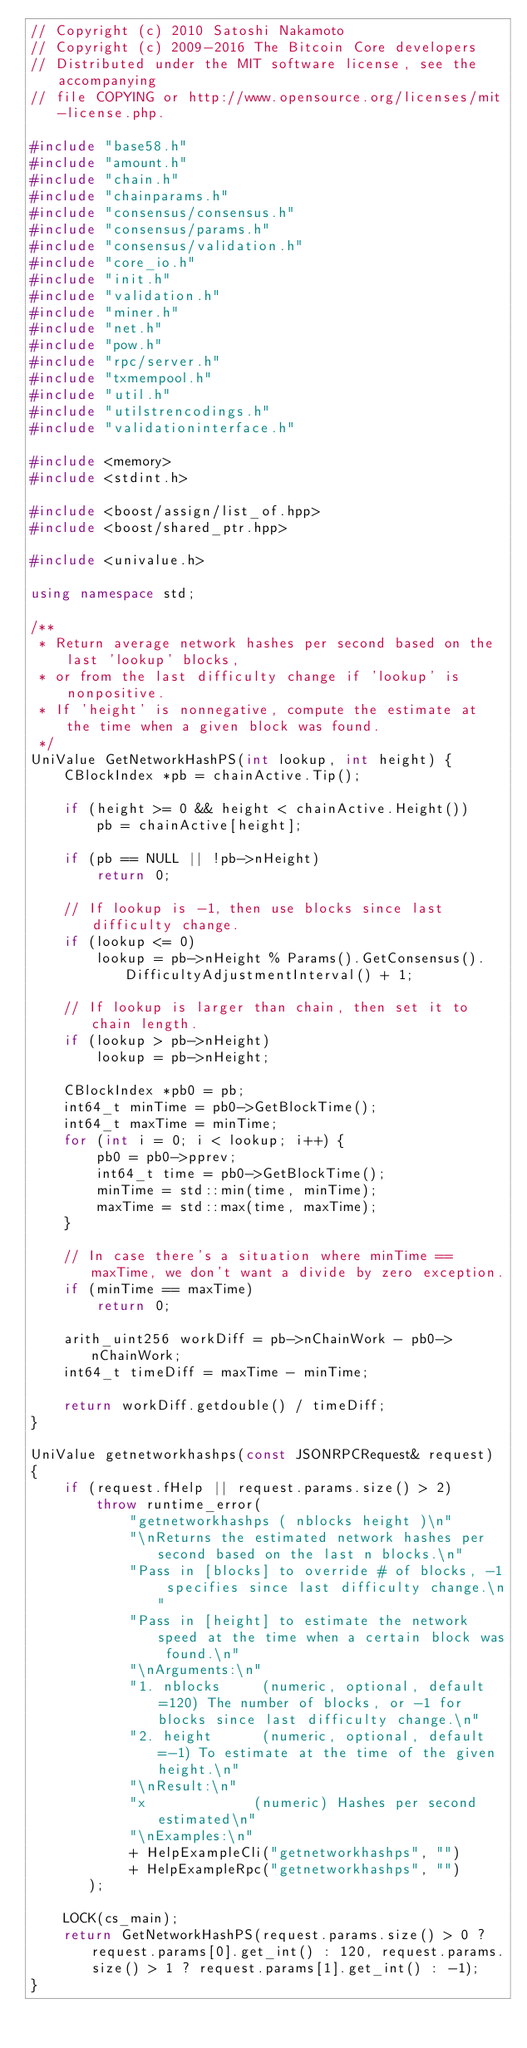<code> <loc_0><loc_0><loc_500><loc_500><_C++_>// Copyright (c) 2010 Satoshi Nakamoto
// Copyright (c) 2009-2016 The Bitcoin Core developers
// Distributed under the MIT software license, see the accompanying
// file COPYING or http://www.opensource.org/licenses/mit-license.php.

#include "base58.h"
#include "amount.h"
#include "chain.h"
#include "chainparams.h"
#include "consensus/consensus.h"
#include "consensus/params.h"
#include "consensus/validation.h"
#include "core_io.h"
#include "init.h"
#include "validation.h"
#include "miner.h"
#include "net.h"
#include "pow.h"
#include "rpc/server.h"
#include "txmempool.h"
#include "util.h"
#include "utilstrencodings.h"
#include "validationinterface.h"

#include <memory>
#include <stdint.h>

#include <boost/assign/list_of.hpp>
#include <boost/shared_ptr.hpp>

#include <univalue.h>

using namespace std;

/**
 * Return average network hashes per second based on the last 'lookup' blocks,
 * or from the last difficulty change if 'lookup' is nonpositive.
 * If 'height' is nonnegative, compute the estimate at the time when a given block was found.
 */
UniValue GetNetworkHashPS(int lookup, int height) {
    CBlockIndex *pb = chainActive.Tip();

    if (height >= 0 && height < chainActive.Height())
        pb = chainActive[height];

    if (pb == NULL || !pb->nHeight)
        return 0;

    // If lookup is -1, then use blocks since last difficulty change.
    if (lookup <= 0)
        lookup = pb->nHeight % Params().GetConsensus().DifficultyAdjustmentInterval() + 1;

    // If lookup is larger than chain, then set it to chain length.
    if (lookup > pb->nHeight)
        lookup = pb->nHeight;

    CBlockIndex *pb0 = pb;
    int64_t minTime = pb0->GetBlockTime();
    int64_t maxTime = minTime;
    for (int i = 0; i < lookup; i++) {
        pb0 = pb0->pprev;
        int64_t time = pb0->GetBlockTime();
        minTime = std::min(time, minTime);
        maxTime = std::max(time, maxTime);
    }

    // In case there's a situation where minTime == maxTime, we don't want a divide by zero exception.
    if (minTime == maxTime)
        return 0;

    arith_uint256 workDiff = pb->nChainWork - pb0->nChainWork;
    int64_t timeDiff = maxTime - minTime;

    return workDiff.getdouble() / timeDiff;
}

UniValue getnetworkhashps(const JSONRPCRequest& request)
{
    if (request.fHelp || request.params.size() > 2)
        throw runtime_error(
            "getnetworkhashps ( nblocks height )\n"
            "\nReturns the estimated network hashes per second based on the last n blocks.\n"
            "Pass in [blocks] to override # of blocks, -1 specifies since last difficulty change.\n"
            "Pass in [height] to estimate the network speed at the time when a certain block was found.\n"
            "\nArguments:\n"
            "1. nblocks     (numeric, optional, default=120) The number of blocks, or -1 for blocks since last difficulty change.\n"
            "2. height      (numeric, optional, default=-1) To estimate at the time of the given height.\n"
            "\nResult:\n"
            "x             (numeric) Hashes per second estimated\n"
            "\nExamples:\n"
            + HelpExampleCli("getnetworkhashps", "")
            + HelpExampleRpc("getnetworkhashps", "")
       );

    LOCK(cs_main);
    return GetNetworkHashPS(request.params.size() > 0 ? request.params[0].get_int() : 120, request.params.size() > 1 ? request.params[1].get_int() : -1);
}
</code> 